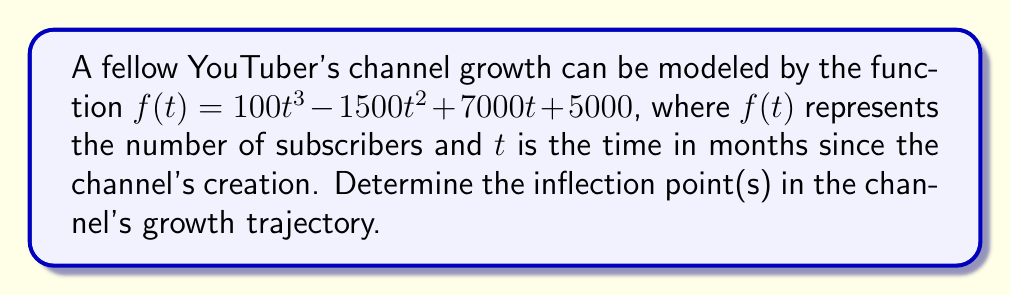Provide a solution to this math problem. To find the inflection points, we need to follow these steps:

1) First, calculate the first derivative of $f(t)$:
   $$f'(t) = 300t^2 - 3000t + 7000$$

2) Then, calculate the second derivative:
   $$f''(t) = 600t - 3000$$

3) The inflection points occur where the second derivative equals zero:
   $$f''(t) = 0$$
   $$600t - 3000 = 0$$
   $$600t = 3000$$
   $$t = 5$$

4) To confirm this is an inflection point, we need to check if the second derivative changes sign around $t = 5$:
   
   At $t = 4$: $f''(4) = 600(4) - 3000 = -600 < 0$
   At $t = 6$: $f''(6) = 600(6) - 3000 = 600 > 0$

   The second derivative changes from negative to positive at $t = 5$, confirming it's an inflection point.

5) To find the number of subscribers at the inflection point, substitute $t = 5$ into the original function:
   
   $$f(5) = 100(5^3) - 1500(5^2) + 7000(5) + 5000$$
   $$= 12500 - 37500 + 35000 + 5000$$
   $$= 15000$$

Therefore, the inflection point occurs at 5 months with 15,000 subscribers.
Answer: (5, 15000) 